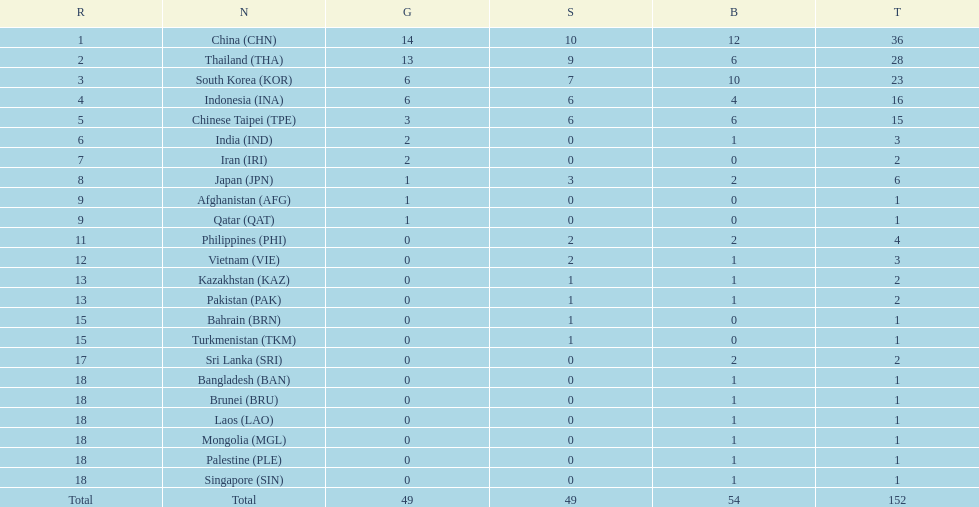What is the total number of nations that participated in the beach games of 2012? 23. 